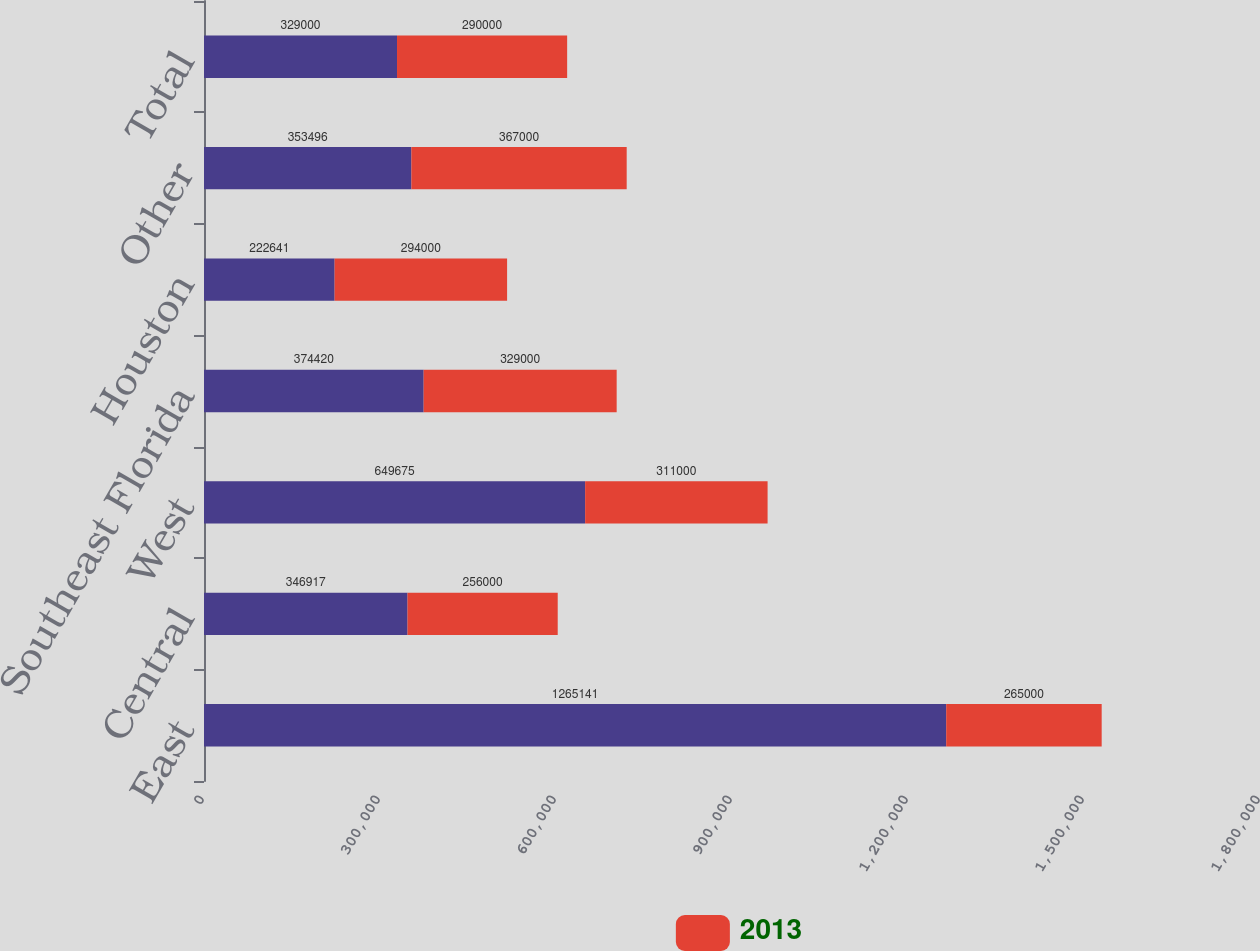<chart> <loc_0><loc_0><loc_500><loc_500><stacked_bar_chart><ecel><fcel>East<fcel>Central<fcel>West<fcel>Southeast Florida<fcel>Houston<fcel>Other<fcel>Total<nl><fcel>nan<fcel>1.26514e+06<fcel>346917<fcel>649675<fcel>374420<fcel>222641<fcel>353496<fcel>329000<nl><fcel>2013<fcel>265000<fcel>256000<fcel>311000<fcel>329000<fcel>294000<fcel>367000<fcel>290000<nl></chart> 